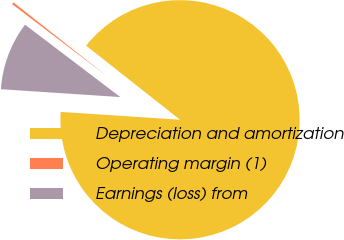Convert chart to OTSL. <chart><loc_0><loc_0><loc_500><loc_500><pie_chart><fcel>Depreciation and amortization<fcel>Operating margin (1)<fcel>Earnings (loss) from<nl><fcel>90.41%<fcel>0.29%<fcel>9.3%<nl></chart> 